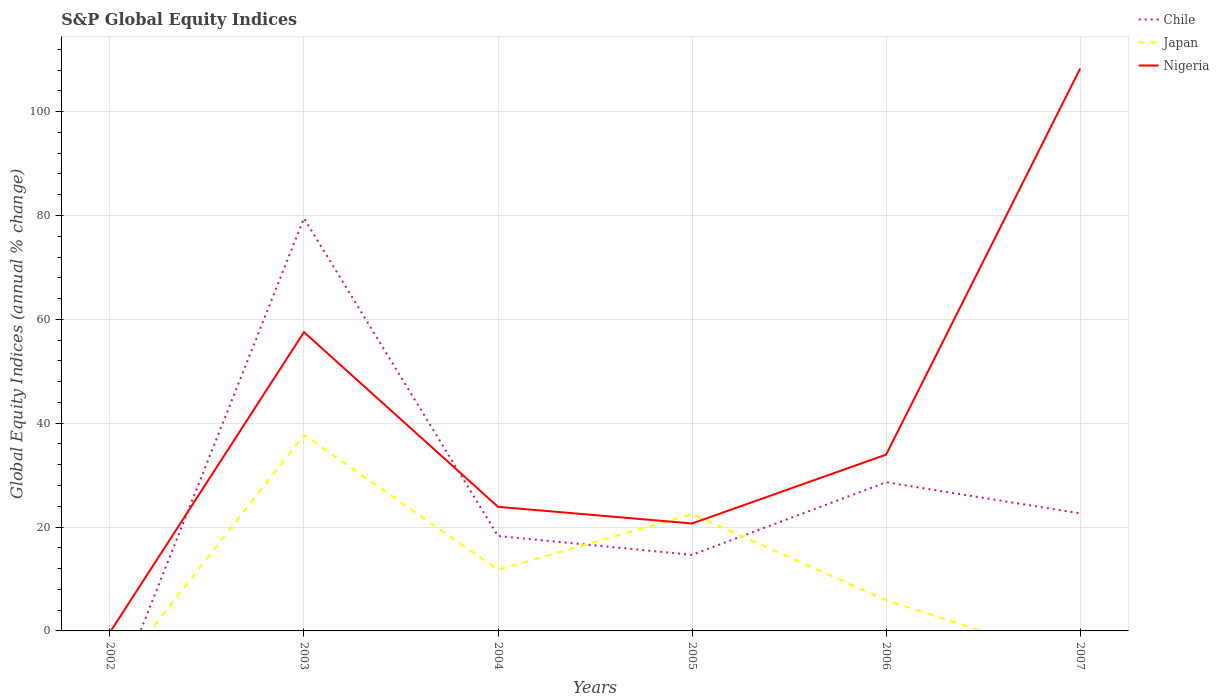How many different coloured lines are there?
Ensure brevity in your answer.  3. Does the line corresponding to Japan intersect with the line corresponding to Nigeria?
Your response must be concise. Yes. Across all years, what is the maximum global equity indices in Nigeria?
Give a very brief answer. 0. What is the total global equity indices in Chile in the graph?
Your response must be concise. 61.19. What is the difference between the highest and the second highest global equity indices in Chile?
Make the answer very short. 79.47. What is the difference between the highest and the lowest global equity indices in Chile?
Your answer should be very brief. 2. How many lines are there?
Give a very brief answer. 3. What is the difference between two consecutive major ticks on the Y-axis?
Your answer should be compact. 20. Are the values on the major ticks of Y-axis written in scientific E-notation?
Your answer should be compact. No. Does the graph contain grids?
Your answer should be very brief. Yes. How many legend labels are there?
Your answer should be compact. 3. What is the title of the graph?
Provide a short and direct response. S&P Global Equity Indices. What is the label or title of the X-axis?
Give a very brief answer. Years. What is the label or title of the Y-axis?
Offer a very short reply. Global Equity Indices (annual % change). What is the Global Equity Indices (annual % change) in Japan in 2002?
Keep it short and to the point. 0. What is the Global Equity Indices (annual % change) of Nigeria in 2002?
Provide a succinct answer. 0. What is the Global Equity Indices (annual % change) of Chile in 2003?
Your answer should be compact. 79.47. What is the Global Equity Indices (annual % change) in Japan in 2003?
Provide a succinct answer. 37.74. What is the Global Equity Indices (annual % change) of Nigeria in 2003?
Provide a short and direct response. 57.54. What is the Global Equity Indices (annual % change) of Chile in 2004?
Offer a very short reply. 18.28. What is the Global Equity Indices (annual % change) in Japan in 2004?
Offer a very short reply. 11.77. What is the Global Equity Indices (annual % change) of Nigeria in 2004?
Provide a short and direct response. 23.9. What is the Global Equity Indices (annual % change) of Chile in 2005?
Keep it short and to the point. 14.65. What is the Global Equity Indices (annual % change) of Japan in 2005?
Keep it short and to the point. 22.5. What is the Global Equity Indices (annual % change) of Nigeria in 2005?
Provide a short and direct response. 20.69. What is the Global Equity Indices (annual % change) in Chile in 2006?
Offer a very short reply. 28.63. What is the Global Equity Indices (annual % change) of Japan in 2006?
Your answer should be compact. 5.92. What is the Global Equity Indices (annual % change) in Nigeria in 2006?
Keep it short and to the point. 33.95. What is the Global Equity Indices (annual % change) of Chile in 2007?
Give a very brief answer. 22.63. What is the Global Equity Indices (annual % change) of Japan in 2007?
Provide a short and direct response. 0. What is the Global Equity Indices (annual % change) in Nigeria in 2007?
Your response must be concise. 108.3. Across all years, what is the maximum Global Equity Indices (annual % change) of Chile?
Your answer should be compact. 79.47. Across all years, what is the maximum Global Equity Indices (annual % change) in Japan?
Provide a succinct answer. 37.74. Across all years, what is the maximum Global Equity Indices (annual % change) of Nigeria?
Provide a succinct answer. 108.3. Across all years, what is the minimum Global Equity Indices (annual % change) of Nigeria?
Offer a very short reply. 0. What is the total Global Equity Indices (annual % change) in Chile in the graph?
Ensure brevity in your answer.  163.66. What is the total Global Equity Indices (annual % change) of Japan in the graph?
Your answer should be very brief. 77.93. What is the total Global Equity Indices (annual % change) in Nigeria in the graph?
Make the answer very short. 244.39. What is the difference between the Global Equity Indices (annual % change) of Chile in 2003 and that in 2004?
Offer a very short reply. 61.19. What is the difference between the Global Equity Indices (annual % change) in Japan in 2003 and that in 2004?
Make the answer very short. 25.97. What is the difference between the Global Equity Indices (annual % change) in Nigeria in 2003 and that in 2004?
Offer a very short reply. 33.64. What is the difference between the Global Equity Indices (annual % change) of Chile in 2003 and that in 2005?
Keep it short and to the point. 64.82. What is the difference between the Global Equity Indices (annual % change) in Japan in 2003 and that in 2005?
Give a very brief answer. 15.24. What is the difference between the Global Equity Indices (annual % change) of Nigeria in 2003 and that in 2005?
Provide a succinct answer. 36.85. What is the difference between the Global Equity Indices (annual % change) in Chile in 2003 and that in 2006?
Provide a short and direct response. 50.84. What is the difference between the Global Equity Indices (annual % change) in Japan in 2003 and that in 2006?
Provide a succinct answer. 31.82. What is the difference between the Global Equity Indices (annual % change) in Nigeria in 2003 and that in 2006?
Ensure brevity in your answer.  23.59. What is the difference between the Global Equity Indices (annual % change) in Chile in 2003 and that in 2007?
Offer a very short reply. 56.84. What is the difference between the Global Equity Indices (annual % change) in Nigeria in 2003 and that in 2007?
Keep it short and to the point. -50.76. What is the difference between the Global Equity Indices (annual % change) of Chile in 2004 and that in 2005?
Provide a succinct answer. 3.63. What is the difference between the Global Equity Indices (annual % change) of Japan in 2004 and that in 2005?
Provide a short and direct response. -10.73. What is the difference between the Global Equity Indices (annual % change) of Nigeria in 2004 and that in 2005?
Your answer should be very brief. 3.21. What is the difference between the Global Equity Indices (annual % change) in Chile in 2004 and that in 2006?
Ensure brevity in your answer.  -10.35. What is the difference between the Global Equity Indices (annual % change) of Japan in 2004 and that in 2006?
Make the answer very short. 5.85. What is the difference between the Global Equity Indices (annual % change) of Nigeria in 2004 and that in 2006?
Give a very brief answer. -10.05. What is the difference between the Global Equity Indices (annual % change) in Chile in 2004 and that in 2007?
Offer a terse response. -4.35. What is the difference between the Global Equity Indices (annual % change) of Nigeria in 2004 and that in 2007?
Give a very brief answer. -84.4. What is the difference between the Global Equity Indices (annual % change) of Chile in 2005 and that in 2006?
Give a very brief answer. -13.98. What is the difference between the Global Equity Indices (annual % change) in Japan in 2005 and that in 2006?
Offer a very short reply. 16.58. What is the difference between the Global Equity Indices (annual % change) of Nigeria in 2005 and that in 2006?
Make the answer very short. -13.26. What is the difference between the Global Equity Indices (annual % change) in Chile in 2005 and that in 2007?
Offer a very short reply. -7.98. What is the difference between the Global Equity Indices (annual % change) in Nigeria in 2005 and that in 2007?
Your response must be concise. -87.61. What is the difference between the Global Equity Indices (annual % change) in Chile in 2006 and that in 2007?
Provide a short and direct response. 6. What is the difference between the Global Equity Indices (annual % change) in Nigeria in 2006 and that in 2007?
Your answer should be very brief. -74.35. What is the difference between the Global Equity Indices (annual % change) in Chile in 2003 and the Global Equity Indices (annual % change) in Japan in 2004?
Offer a terse response. 67.7. What is the difference between the Global Equity Indices (annual % change) of Chile in 2003 and the Global Equity Indices (annual % change) of Nigeria in 2004?
Provide a succinct answer. 55.57. What is the difference between the Global Equity Indices (annual % change) in Japan in 2003 and the Global Equity Indices (annual % change) in Nigeria in 2004?
Give a very brief answer. 13.84. What is the difference between the Global Equity Indices (annual % change) in Chile in 2003 and the Global Equity Indices (annual % change) in Japan in 2005?
Give a very brief answer. 56.97. What is the difference between the Global Equity Indices (annual % change) in Chile in 2003 and the Global Equity Indices (annual % change) in Nigeria in 2005?
Your answer should be very brief. 58.78. What is the difference between the Global Equity Indices (annual % change) in Japan in 2003 and the Global Equity Indices (annual % change) in Nigeria in 2005?
Your answer should be very brief. 17.05. What is the difference between the Global Equity Indices (annual % change) of Chile in 2003 and the Global Equity Indices (annual % change) of Japan in 2006?
Offer a very short reply. 73.55. What is the difference between the Global Equity Indices (annual % change) in Chile in 2003 and the Global Equity Indices (annual % change) in Nigeria in 2006?
Make the answer very short. 45.52. What is the difference between the Global Equity Indices (annual % change) in Japan in 2003 and the Global Equity Indices (annual % change) in Nigeria in 2006?
Your answer should be compact. 3.79. What is the difference between the Global Equity Indices (annual % change) of Chile in 2003 and the Global Equity Indices (annual % change) of Nigeria in 2007?
Make the answer very short. -28.83. What is the difference between the Global Equity Indices (annual % change) in Japan in 2003 and the Global Equity Indices (annual % change) in Nigeria in 2007?
Your response must be concise. -70.56. What is the difference between the Global Equity Indices (annual % change) in Chile in 2004 and the Global Equity Indices (annual % change) in Japan in 2005?
Your response must be concise. -4.22. What is the difference between the Global Equity Indices (annual % change) in Chile in 2004 and the Global Equity Indices (annual % change) in Nigeria in 2005?
Provide a succinct answer. -2.41. What is the difference between the Global Equity Indices (annual % change) of Japan in 2004 and the Global Equity Indices (annual % change) of Nigeria in 2005?
Make the answer very short. -8.92. What is the difference between the Global Equity Indices (annual % change) of Chile in 2004 and the Global Equity Indices (annual % change) of Japan in 2006?
Your answer should be very brief. 12.36. What is the difference between the Global Equity Indices (annual % change) in Chile in 2004 and the Global Equity Indices (annual % change) in Nigeria in 2006?
Provide a succinct answer. -15.67. What is the difference between the Global Equity Indices (annual % change) in Japan in 2004 and the Global Equity Indices (annual % change) in Nigeria in 2006?
Offer a very short reply. -22.18. What is the difference between the Global Equity Indices (annual % change) in Chile in 2004 and the Global Equity Indices (annual % change) in Nigeria in 2007?
Make the answer very short. -90.02. What is the difference between the Global Equity Indices (annual % change) in Japan in 2004 and the Global Equity Indices (annual % change) in Nigeria in 2007?
Ensure brevity in your answer.  -96.53. What is the difference between the Global Equity Indices (annual % change) in Chile in 2005 and the Global Equity Indices (annual % change) in Japan in 2006?
Give a very brief answer. 8.73. What is the difference between the Global Equity Indices (annual % change) of Chile in 2005 and the Global Equity Indices (annual % change) of Nigeria in 2006?
Offer a very short reply. -19.3. What is the difference between the Global Equity Indices (annual % change) of Japan in 2005 and the Global Equity Indices (annual % change) of Nigeria in 2006?
Your response must be concise. -11.45. What is the difference between the Global Equity Indices (annual % change) in Chile in 2005 and the Global Equity Indices (annual % change) in Nigeria in 2007?
Offer a very short reply. -93.65. What is the difference between the Global Equity Indices (annual % change) of Japan in 2005 and the Global Equity Indices (annual % change) of Nigeria in 2007?
Give a very brief answer. -85.8. What is the difference between the Global Equity Indices (annual % change) in Chile in 2006 and the Global Equity Indices (annual % change) in Nigeria in 2007?
Make the answer very short. -79.68. What is the difference between the Global Equity Indices (annual % change) of Japan in 2006 and the Global Equity Indices (annual % change) of Nigeria in 2007?
Your answer should be very brief. -102.38. What is the average Global Equity Indices (annual % change) of Chile per year?
Ensure brevity in your answer.  27.28. What is the average Global Equity Indices (annual % change) in Japan per year?
Ensure brevity in your answer.  12.99. What is the average Global Equity Indices (annual % change) in Nigeria per year?
Offer a very short reply. 40.73. In the year 2003, what is the difference between the Global Equity Indices (annual % change) of Chile and Global Equity Indices (annual % change) of Japan?
Your answer should be very brief. 41.73. In the year 2003, what is the difference between the Global Equity Indices (annual % change) in Chile and Global Equity Indices (annual % change) in Nigeria?
Your response must be concise. 21.93. In the year 2003, what is the difference between the Global Equity Indices (annual % change) of Japan and Global Equity Indices (annual % change) of Nigeria?
Keep it short and to the point. -19.8. In the year 2004, what is the difference between the Global Equity Indices (annual % change) of Chile and Global Equity Indices (annual % change) of Japan?
Offer a very short reply. 6.51. In the year 2004, what is the difference between the Global Equity Indices (annual % change) in Chile and Global Equity Indices (annual % change) in Nigeria?
Your response must be concise. -5.62. In the year 2004, what is the difference between the Global Equity Indices (annual % change) in Japan and Global Equity Indices (annual % change) in Nigeria?
Give a very brief answer. -12.13. In the year 2005, what is the difference between the Global Equity Indices (annual % change) of Chile and Global Equity Indices (annual % change) of Japan?
Your answer should be very brief. -7.85. In the year 2005, what is the difference between the Global Equity Indices (annual % change) in Chile and Global Equity Indices (annual % change) in Nigeria?
Your answer should be compact. -6.04. In the year 2005, what is the difference between the Global Equity Indices (annual % change) of Japan and Global Equity Indices (annual % change) of Nigeria?
Your answer should be very brief. 1.81. In the year 2006, what is the difference between the Global Equity Indices (annual % change) of Chile and Global Equity Indices (annual % change) of Japan?
Give a very brief answer. 22.71. In the year 2006, what is the difference between the Global Equity Indices (annual % change) of Chile and Global Equity Indices (annual % change) of Nigeria?
Keep it short and to the point. -5.32. In the year 2006, what is the difference between the Global Equity Indices (annual % change) of Japan and Global Equity Indices (annual % change) of Nigeria?
Provide a succinct answer. -28.03. In the year 2007, what is the difference between the Global Equity Indices (annual % change) of Chile and Global Equity Indices (annual % change) of Nigeria?
Offer a terse response. -85.67. What is the ratio of the Global Equity Indices (annual % change) in Chile in 2003 to that in 2004?
Make the answer very short. 4.35. What is the ratio of the Global Equity Indices (annual % change) in Japan in 2003 to that in 2004?
Your answer should be very brief. 3.21. What is the ratio of the Global Equity Indices (annual % change) in Nigeria in 2003 to that in 2004?
Give a very brief answer. 2.41. What is the ratio of the Global Equity Indices (annual % change) in Chile in 2003 to that in 2005?
Your answer should be compact. 5.42. What is the ratio of the Global Equity Indices (annual % change) of Japan in 2003 to that in 2005?
Your answer should be compact. 1.68. What is the ratio of the Global Equity Indices (annual % change) in Nigeria in 2003 to that in 2005?
Keep it short and to the point. 2.78. What is the ratio of the Global Equity Indices (annual % change) of Chile in 2003 to that in 2006?
Provide a succinct answer. 2.78. What is the ratio of the Global Equity Indices (annual % change) in Japan in 2003 to that in 2006?
Your answer should be very brief. 6.37. What is the ratio of the Global Equity Indices (annual % change) of Nigeria in 2003 to that in 2006?
Your answer should be very brief. 1.69. What is the ratio of the Global Equity Indices (annual % change) in Chile in 2003 to that in 2007?
Offer a terse response. 3.51. What is the ratio of the Global Equity Indices (annual % change) of Nigeria in 2003 to that in 2007?
Your response must be concise. 0.53. What is the ratio of the Global Equity Indices (annual % change) of Chile in 2004 to that in 2005?
Your answer should be compact. 1.25. What is the ratio of the Global Equity Indices (annual % change) of Japan in 2004 to that in 2005?
Give a very brief answer. 0.52. What is the ratio of the Global Equity Indices (annual % change) in Nigeria in 2004 to that in 2005?
Make the answer very short. 1.16. What is the ratio of the Global Equity Indices (annual % change) in Chile in 2004 to that in 2006?
Give a very brief answer. 0.64. What is the ratio of the Global Equity Indices (annual % change) in Japan in 2004 to that in 2006?
Give a very brief answer. 1.99. What is the ratio of the Global Equity Indices (annual % change) in Nigeria in 2004 to that in 2006?
Give a very brief answer. 0.7. What is the ratio of the Global Equity Indices (annual % change) of Chile in 2004 to that in 2007?
Give a very brief answer. 0.81. What is the ratio of the Global Equity Indices (annual % change) of Nigeria in 2004 to that in 2007?
Keep it short and to the point. 0.22. What is the ratio of the Global Equity Indices (annual % change) of Chile in 2005 to that in 2006?
Your response must be concise. 0.51. What is the ratio of the Global Equity Indices (annual % change) of Japan in 2005 to that in 2006?
Provide a succinct answer. 3.8. What is the ratio of the Global Equity Indices (annual % change) of Nigeria in 2005 to that in 2006?
Ensure brevity in your answer.  0.61. What is the ratio of the Global Equity Indices (annual % change) in Chile in 2005 to that in 2007?
Your answer should be compact. 0.65. What is the ratio of the Global Equity Indices (annual % change) of Nigeria in 2005 to that in 2007?
Offer a terse response. 0.19. What is the ratio of the Global Equity Indices (annual % change) of Chile in 2006 to that in 2007?
Keep it short and to the point. 1.26. What is the ratio of the Global Equity Indices (annual % change) in Nigeria in 2006 to that in 2007?
Keep it short and to the point. 0.31. What is the difference between the highest and the second highest Global Equity Indices (annual % change) in Chile?
Provide a short and direct response. 50.84. What is the difference between the highest and the second highest Global Equity Indices (annual % change) of Japan?
Offer a terse response. 15.24. What is the difference between the highest and the second highest Global Equity Indices (annual % change) in Nigeria?
Provide a short and direct response. 50.76. What is the difference between the highest and the lowest Global Equity Indices (annual % change) in Chile?
Keep it short and to the point. 79.47. What is the difference between the highest and the lowest Global Equity Indices (annual % change) of Japan?
Your answer should be compact. 37.74. What is the difference between the highest and the lowest Global Equity Indices (annual % change) of Nigeria?
Offer a terse response. 108.3. 